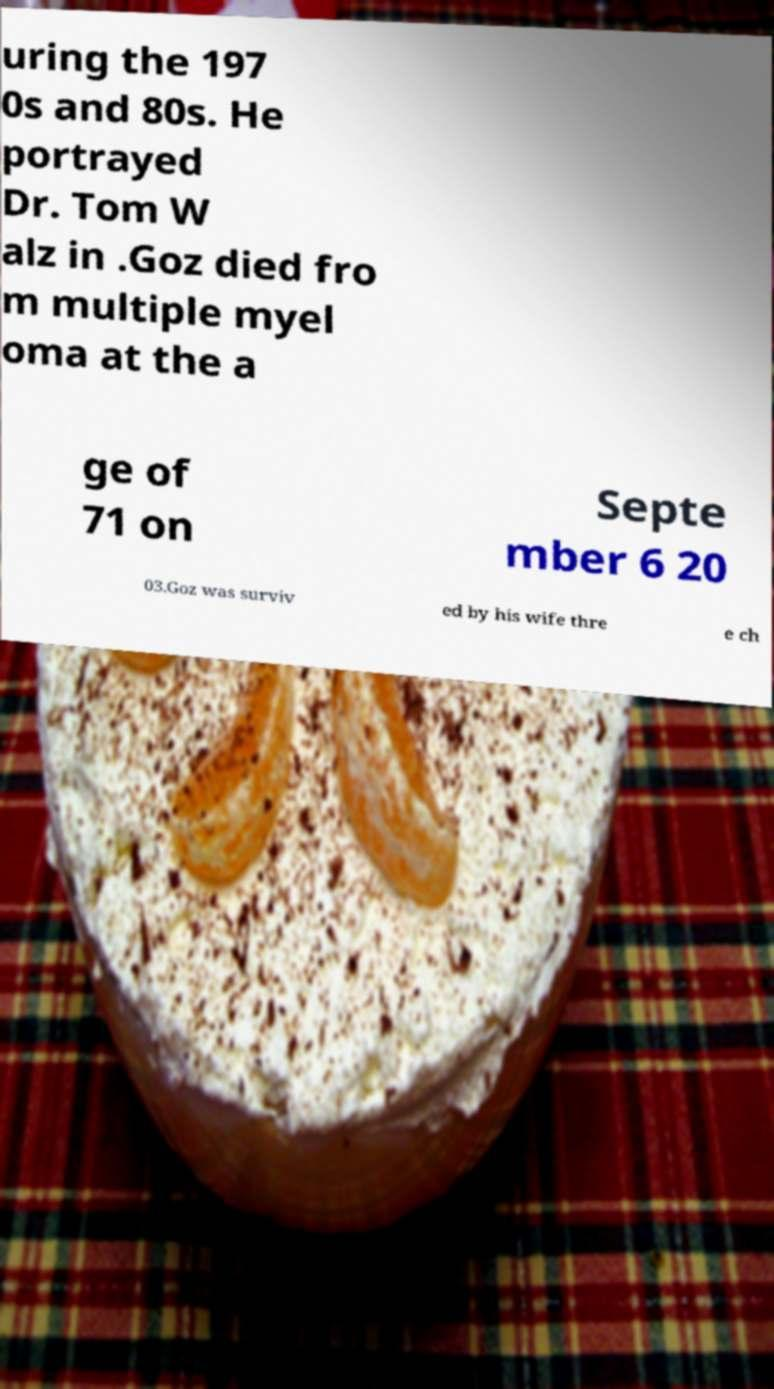Please read and relay the text visible in this image. What does it say? uring the 197 0s and 80s. He portrayed Dr. Tom W alz in .Goz died fro m multiple myel oma at the a ge of 71 on Septe mber 6 20 03.Goz was surviv ed by his wife thre e ch 